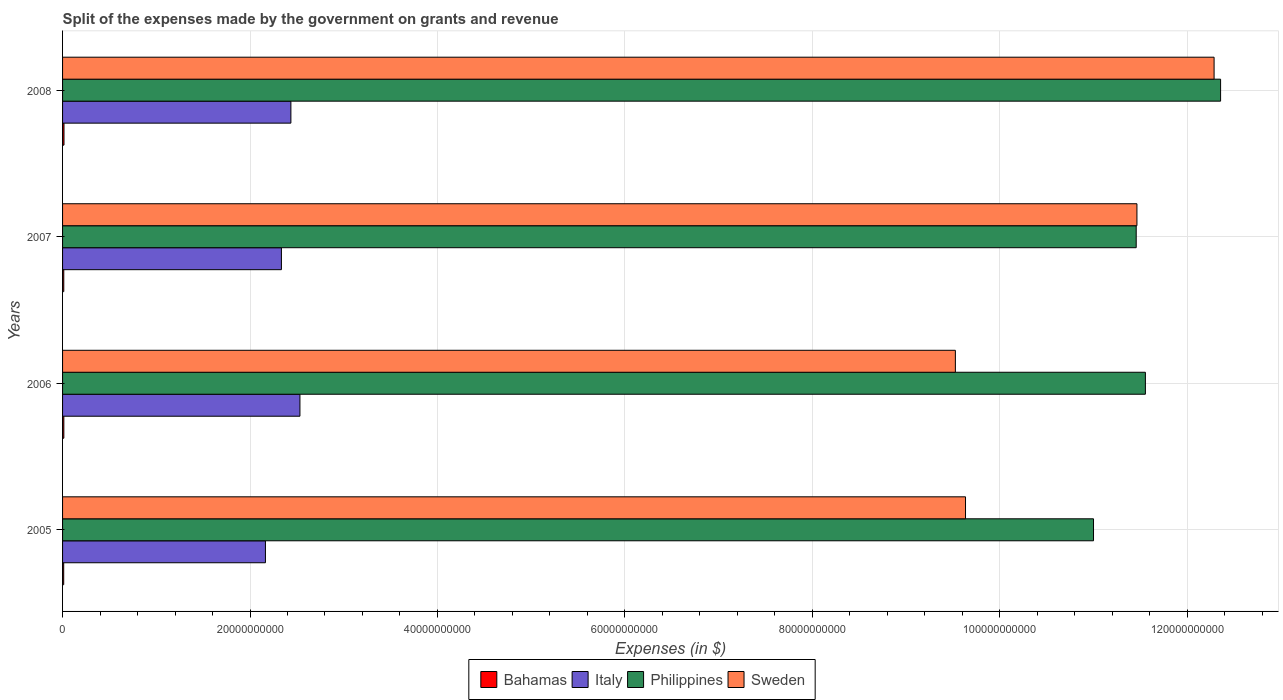How many different coloured bars are there?
Your answer should be compact. 4. Are the number of bars per tick equal to the number of legend labels?
Make the answer very short. Yes. How many bars are there on the 3rd tick from the top?
Provide a succinct answer. 4. How many bars are there on the 1st tick from the bottom?
Keep it short and to the point. 4. What is the label of the 4th group of bars from the top?
Keep it short and to the point. 2005. In how many cases, is the number of bars for a given year not equal to the number of legend labels?
Offer a very short reply. 0. What is the expenses made by the government on grants and revenue in Sweden in 2008?
Provide a short and direct response. 1.23e+11. Across all years, what is the maximum expenses made by the government on grants and revenue in Sweden?
Offer a terse response. 1.23e+11. Across all years, what is the minimum expenses made by the government on grants and revenue in Bahamas?
Your answer should be compact. 1.21e+08. In which year was the expenses made by the government on grants and revenue in Philippines maximum?
Your answer should be compact. 2008. In which year was the expenses made by the government on grants and revenue in Sweden minimum?
Your response must be concise. 2006. What is the total expenses made by the government on grants and revenue in Italy in the graph?
Provide a short and direct response. 9.47e+1. What is the difference between the expenses made by the government on grants and revenue in Philippines in 2005 and that in 2006?
Offer a terse response. -5.54e+09. What is the difference between the expenses made by the government on grants and revenue in Sweden in 2006 and the expenses made by the government on grants and revenue in Italy in 2007?
Offer a very short reply. 7.19e+1. What is the average expenses made by the government on grants and revenue in Bahamas per year?
Ensure brevity in your answer.  1.35e+08. In the year 2005, what is the difference between the expenses made by the government on grants and revenue in Philippines and expenses made by the government on grants and revenue in Sweden?
Give a very brief answer. 1.37e+1. What is the ratio of the expenses made by the government on grants and revenue in Philippines in 2007 to that in 2008?
Your response must be concise. 0.93. What is the difference between the highest and the second highest expenses made by the government on grants and revenue in Bahamas?
Keep it short and to the point. 1.60e+07. What is the difference between the highest and the lowest expenses made by the government on grants and revenue in Italy?
Ensure brevity in your answer.  3.68e+09. In how many years, is the expenses made by the government on grants and revenue in Bahamas greater than the average expenses made by the government on grants and revenue in Bahamas taken over all years?
Provide a short and direct response. 2. Is the sum of the expenses made by the government on grants and revenue in Italy in 2007 and 2008 greater than the maximum expenses made by the government on grants and revenue in Bahamas across all years?
Your answer should be very brief. Yes. How many bars are there?
Your response must be concise. 16. Are the values on the major ticks of X-axis written in scientific E-notation?
Keep it short and to the point. No. Where does the legend appear in the graph?
Your answer should be compact. Bottom center. How many legend labels are there?
Offer a terse response. 4. What is the title of the graph?
Provide a short and direct response. Split of the expenses made by the government on grants and revenue. What is the label or title of the X-axis?
Your answer should be very brief. Expenses (in $). What is the label or title of the Y-axis?
Your answer should be compact. Years. What is the Expenses (in $) of Bahamas in 2005?
Give a very brief answer. 1.21e+08. What is the Expenses (in $) of Italy in 2005?
Ensure brevity in your answer.  2.16e+1. What is the Expenses (in $) in Philippines in 2005?
Provide a short and direct response. 1.10e+11. What is the Expenses (in $) of Sweden in 2005?
Offer a terse response. 9.64e+1. What is the Expenses (in $) of Bahamas in 2006?
Your answer should be compact. 1.37e+08. What is the Expenses (in $) of Italy in 2006?
Offer a very short reply. 2.53e+1. What is the Expenses (in $) of Philippines in 2006?
Make the answer very short. 1.16e+11. What is the Expenses (in $) of Sweden in 2006?
Offer a very short reply. 9.53e+1. What is the Expenses (in $) in Bahamas in 2007?
Ensure brevity in your answer.  1.30e+08. What is the Expenses (in $) in Italy in 2007?
Provide a succinct answer. 2.34e+1. What is the Expenses (in $) in Philippines in 2007?
Provide a short and direct response. 1.15e+11. What is the Expenses (in $) of Sweden in 2007?
Keep it short and to the point. 1.15e+11. What is the Expenses (in $) of Bahamas in 2008?
Ensure brevity in your answer.  1.53e+08. What is the Expenses (in $) in Italy in 2008?
Offer a very short reply. 2.44e+1. What is the Expenses (in $) in Philippines in 2008?
Offer a terse response. 1.24e+11. What is the Expenses (in $) of Sweden in 2008?
Provide a succinct answer. 1.23e+11. Across all years, what is the maximum Expenses (in $) in Bahamas?
Keep it short and to the point. 1.53e+08. Across all years, what is the maximum Expenses (in $) in Italy?
Your answer should be compact. 2.53e+1. Across all years, what is the maximum Expenses (in $) in Philippines?
Your response must be concise. 1.24e+11. Across all years, what is the maximum Expenses (in $) of Sweden?
Offer a terse response. 1.23e+11. Across all years, what is the minimum Expenses (in $) of Bahamas?
Offer a very short reply. 1.21e+08. Across all years, what is the minimum Expenses (in $) of Italy?
Your answer should be very brief. 2.16e+1. Across all years, what is the minimum Expenses (in $) in Philippines?
Your answer should be compact. 1.10e+11. Across all years, what is the minimum Expenses (in $) in Sweden?
Provide a succinct answer. 9.53e+1. What is the total Expenses (in $) of Bahamas in the graph?
Provide a short and direct response. 5.41e+08. What is the total Expenses (in $) of Italy in the graph?
Keep it short and to the point. 9.47e+1. What is the total Expenses (in $) of Philippines in the graph?
Your answer should be very brief. 4.64e+11. What is the total Expenses (in $) of Sweden in the graph?
Give a very brief answer. 4.29e+11. What is the difference between the Expenses (in $) of Bahamas in 2005 and that in 2006?
Offer a terse response. -1.59e+07. What is the difference between the Expenses (in $) in Italy in 2005 and that in 2006?
Provide a succinct answer. -3.68e+09. What is the difference between the Expenses (in $) in Philippines in 2005 and that in 2006?
Your answer should be very brief. -5.54e+09. What is the difference between the Expenses (in $) in Sweden in 2005 and that in 2006?
Offer a terse response. 1.08e+09. What is the difference between the Expenses (in $) of Bahamas in 2005 and that in 2007?
Give a very brief answer. -9.02e+06. What is the difference between the Expenses (in $) in Italy in 2005 and that in 2007?
Offer a very short reply. -1.71e+09. What is the difference between the Expenses (in $) in Philippines in 2005 and that in 2007?
Provide a succinct answer. -4.56e+09. What is the difference between the Expenses (in $) in Sweden in 2005 and that in 2007?
Your answer should be compact. -1.83e+1. What is the difference between the Expenses (in $) in Bahamas in 2005 and that in 2008?
Offer a very short reply. -3.18e+07. What is the difference between the Expenses (in $) of Italy in 2005 and that in 2008?
Provide a succinct answer. -2.72e+09. What is the difference between the Expenses (in $) of Philippines in 2005 and that in 2008?
Your answer should be very brief. -1.36e+1. What is the difference between the Expenses (in $) in Sweden in 2005 and that in 2008?
Give a very brief answer. -2.65e+1. What is the difference between the Expenses (in $) in Bahamas in 2006 and that in 2007?
Your response must be concise. 6.84e+06. What is the difference between the Expenses (in $) of Italy in 2006 and that in 2007?
Ensure brevity in your answer.  1.98e+09. What is the difference between the Expenses (in $) of Philippines in 2006 and that in 2007?
Offer a terse response. 9.80e+08. What is the difference between the Expenses (in $) of Sweden in 2006 and that in 2007?
Your answer should be compact. -1.94e+1. What is the difference between the Expenses (in $) of Bahamas in 2006 and that in 2008?
Your answer should be very brief. -1.60e+07. What is the difference between the Expenses (in $) of Italy in 2006 and that in 2008?
Offer a terse response. 9.65e+08. What is the difference between the Expenses (in $) of Philippines in 2006 and that in 2008?
Give a very brief answer. -8.02e+09. What is the difference between the Expenses (in $) of Sweden in 2006 and that in 2008?
Your answer should be very brief. -2.76e+1. What is the difference between the Expenses (in $) in Bahamas in 2007 and that in 2008?
Offer a terse response. -2.28e+07. What is the difference between the Expenses (in $) in Italy in 2007 and that in 2008?
Give a very brief answer. -1.01e+09. What is the difference between the Expenses (in $) of Philippines in 2007 and that in 2008?
Provide a short and direct response. -9.00e+09. What is the difference between the Expenses (in $) in Sweden in 2007 and that in 2008?
Ensure brevity in your answer.  -8.23e+09. What is the difference between the Expenses (in $) in Bahamas in 2005 and the Expenses (in $) in Italy in 2006?
Provide a succinct answer. -2.52e+1. What is the difference between the Expenses (in $) of Bahamas in 2005 and the Expenses (in $) of Philippines in 2006?
Offer a very short reply. -1.15e+11. What is the difference between the Expenses (in $) in Bahamas in 2005 and the Expenses (in $) in Sweden in 2006?
Provide a succinct answer. -9.51e+1. What is the difference between the Expenses (in $) of Italy in 2005 and the Expenses (in $) of Philippines in 2006?
Your response must be concise. -9.39e+1. What is the difference between the Expenses (in $) in Italy in 2005 and the Expenses (in $) in Sweden in 2006?
Your answer should be very brief. -7.36e+1. What is the difference between the Expenses (in $) of Philippines in 2005 and the Expenses (in $) of Sweden in 2006?
Offer a terse response. 1.47e+1. What is the difference between the Expenses (in $) in Bahamas in 2005 and the Expenses (in $) in Italy in 2007?
Make the answer very short. -2.32e+1. What is the difference between the Expenses (in $) in Bahamas in 2005 and the Expenses (in $) in Philippines in 2007?
Provide a short and direct response. -1.14e+11. What is the difference between the Expenses (in $) of Bahamas in 2005 and the Expenses (in $) of Sweden in 2007?
Offer a terse response. -1.15e+11. What is the difference between the Expenses (in $) of Italy in 2005 and the Expenses (in $) of Philippines in 2007?
Make the answer very short. -9.29e+1. What is the difference between the Expenses (in $) in Italy in 2005 and the Expenses (in $) in Sweden in 2007?
Keep it short and to the point. -9.30e+1. What is the difference between the Expenses (in $) in Philippines in 2005 and the Expenses (in $) in Sweden in 2007?
Give a very brief answer. -4.63e+09. What is the difference between the Expenses (in $) in Bahamas in 2005 and the Expenses (in $) in Italy in 2008?
Provide a short and direct response. -2.42e+1. What is the difference between the Expenses (in $) of Bahamas in 2005 and the Expenses (in $) of Philippines in 2008?
Your response must be concise. -1.23e+11. What is the difference between the Expenses (in $) in Bahamas in 2005 and the Expenses (in $) in Sweden in 2008?
Your response must be concise. -1.23e+11. What is the difference between the Expenses (in $) in Italy in 2005 and the Expenses (in $) in Philippines in 2008?
Make the answer very short. -1.02e+11. What is the difference between the Expenses (in $) in Italy in 2005 and the Expenses (in $) in Sweden in 2008?
Offer a very short reply. -1.01e+11. What is the difference between the Expenses (in $) in Philippines in 2005 and the Expenses (in $) in Sweden in 2008?
Ensure brevity in your answer.  -1.29e+1. What is the difference between the Expenses (in $) in Bahamas in 2006 and the Expenses (in $) in Italy in 2007?
Your response must be concise. -2.32e+1. What is the difference between the Expenses (in $) of Bahamas in 2006 and the Expenses (in $) of Philippines in 2007?
Your answer should be compact. -1.14e+11. What is the difference between the Expenses (in $) of Bahamas in 2006 and the Expenses (in $) of Sweden in 2007?
Give a very brief answer. -1.15e+11. What is the difference between the Expenses (in $) in Italy in 2006 and the Expenses (in $) in Philippines in 2007?
Offer a very short reply. -8.92e+1. What is the difference between the Expenses (in $) of Italy in 2006 and the Expenses (in $) of Sweden in 2007?
Your answer should be compact. -8.93e+1. What is the difference between the Expenses (in $) of Philippines in 2006 and the Expenses (in $) of Sweden in 2007?
Provide a short and direct response. 9.02e+08. What is the difference between the Expenses (in $) in Bahamas in 2006 and the Expenses (in $) in Italy in 2008?
Your answer should be compact. -2.42e+1. What is the difference between the Expenses (in $) of Bahamas in 2006 and the Expenses (in $) of Philippines in 2008?
Offer a very short reply. -1.23e+11. What is the difference between the Expenses (in $) in Bahamas in 2006 and the Expenses (in $) in Sweden in 2008?
Give a very brief answer. -1.23e+11. What is the difference between the Expenses (in $) of Italy in 2006 and the Expenses (in $) of Philippines in 2008?
Ensure brevity in your answer.  -9.82e+1. What is the difference between the Expenses (in $) of Italy in 2006 and the Expenses (in $) of Sweden in 2008?
Provide a succinct answer. -9.75e+1. What is the difference between the Expenses (in $) of Philippines in 2006 and the Expenses (in $) of Sweden in 2008?
Your response must be concise. -7.33e+09. What is the difference between the Expenses (in $) in Bahamas in 2007 and the Expenses (in $) in Italy in 2008?
Provide a short and direct response. -2.42e+1. What is the difference between the Expenses (in $) in Bahamas in 2007 and the Expenses (in $) in Philippines in 2008?
Your answer should be very brief. -1.23e+11. What is the difference between the Expenses (in $) of Bahamas in 2007 and the Expenses (in $) of Sweden in 2008?
Offer a terse response. -1.23e+11. What is the difference between the Expenses (in $) of Italy in 2007 and the Expenses (in $) of Philippines in 2008?
Ensure brevity in your answer.  -1.00e+11. What is the difference between the Expenses (in $) in Italy in 2007 and the Expenses (in $) in Sweden in 2008?
Provide a succinct answer. -9.95e+1. What is the difference between the Expenses (in $) of Philippines in 2007 and the Expenses (in $) of Sweden in 2008?
Ensure brevity in your answer.  -8.31e+09. What is the average Expenses (in $) in Bahamas per year?
Your answer should be very brief. 1.35e+08. What is the average Expenses (in $) of Italy per year?
Give a very brief answer. 2.37e+1. What is the average Expenses (in $) in Philippines per year?
Your answer should be compact. 1.16e+11. What is the average Expenses (in $) of Sweden per year?
Provide a succinct answer. 1.07e+11. In the year 2005, what is the difference between the Expenses (in $) of Bahamas and Expenses (in $) of Italy?
Ensure brevity in your answer.  -2.15e+1. In the year 2005, what is the difference between the Expenses (in $) in Bahamas and Expenses (in $) in Philippines?
Offer a terse response. -1.10e+11. In the year 2005, what is the difference between the Expenses (in $) in Bahamas and Expenses (in $) in Sweden?
Provide a short and direct response. -9.62e+1. In the year 2005, what is the difference between the Expenses (in $) in Italy and Expenses (in $) in Philippines?
Your answer should be very brief. -8.84e+1. In the year 2005, what is the difference between the Expenses (in $) of Italy and Expenses (in $) of Sweden?
Ensure brevity in your answer.  -7.47e+1. In the year 2005, what is the difference between the Expenses (in $) of Philippines and Expenses (in $) of Sweden?
Give a very brief answer. 1.37e+1. In the year 2006, what is the difference between the Expenses (in $) in Bahamas and Expenses (in $) in Italy?
Your answer should be very brief. -2.52e+1. In the year 2006, what is the difference between the Expenses (in $) in Bahamas and Expenses (in $) in Philippines?
Provide a succinct answer. -1.15e+11. In the year 2006, what is the difference between the Expenses (in $) of Bahamas and Expenses (in $) of Sweden?
Your answer should be compact. -9.51e+1. In the year 2006, what is the difference between the Expenses (in $) of Italy and Expenses (in $) of Philippines?
Ensure brevity in your answer.  -9.02e+1. In the year 2006, what is the difference between the Expenses (in $) of Italy and Expenses (in $) of Sweden?
Your answer should be very brief. -6.99e+1. In the year 2006, what is the difference between the Expenses (in $) in Philippines and Expenses (in $) in Sweden?
Keep it short and to the point. 2.03e+1. In the year 2007, what is the difference between the Expenses (in $) of Bahamas and Expenses (in $) of Italy?
Ensure brevity in your answer.  -2.32e+1. In the year 2007, what is the difference between the Expenses (in $) of Bahamas and Expenses (in $) of Philippines?
Ensure brevity in your answer.  -1.14e+11. In the year 2007, what is the difference between the Expenses (in $) in Bahamas and Expenses (in $) in Sweden?
Give a very brief answer. -1.15e+11. In the year 2007, what is the difference between the Expenses (in $) of Italy and Expenses (in $) of Philippines?
Keep it short and to the point. -9.12e+1. In the year 2007, what is the difference between the Expenses (in $) of Italy and Expenses (in $) of Sweden?
Your answer should be very brief. -9.13e+1. In the year 2007, what is the difference between the Expenses (in $) in Philippines and Expenses (in $) in Sweden?
Your response must be concise. -7.80e+07. In the year 2008, what is the difference between the Expenses (in $) in Bahamas and Expenses (in $) in Italy?
Provide a short and direct response. -2.42e+1. In the year 2008, what is the difference between the Expenses (in $) of Bahamas and Expenses (in $) of Philippines?
Provide a short and direct response. -1.23e+11. In the year 2008, what is the difference between the Expenses (in $) in Bahamas and Expenses (in $) in Sweden?
Provide a succinct answer. -1.23e+11. In the year 2008, what is the difference between the Expenses (in $) of Italy and Expenses (in $) of Philippines?
Offer a very short reply. -9.92e+1. In the year 2008, what is the difference between the Expenses (in $) of Italy and Expenses (in $) of Sweden?
Your answer should be compact. -9.85e+1. In the year 2008, what is the difference between the Expenses (in $) of Philippines and Expenses (in $) of Sweden?
Offer a very short reply. 6.94e+08. What is the ratio of the Expenses (in $) in Bahamas in 2005 to that in 2006?
Your answer should be very brief. 0.88. What is the ratio of the Expenses (in $) of Italy in 2005 to that in 2006?
Provide a succinct answer. 0.85. What is the ratio of the Expenses (in $) of Philippines in 2005 to that in 2006?
Your answer should be very brief. 0.95. What is the ratio of the Expenses (in $) of Sweden in 2005 to that in 2006?
Your answer should be compact. 1.01. What is the ratio of the Expenses (in $) of Bahamas in 2005 to that in 2007?
Your answer should be compact. 0.93. What is the ratio of the Expenses (in $) of Italy in 2005 to that in 2007?
Make the answer very short. 0.93. What is the ratio of the Expenses (in $) of Philippines in 2005 to that in 2007?
Give a very brief answer. 0.96. What is the ratio of the Expenses (in $) of Sweden in 2005 to that in 2007?
Ensure brevity in your answer.  0.84. What is the ratio of the Expenses (in $) in Bahamas in 2005 to that in 2008?
Provide a short and direct response. 0.79. What is the ratio of the Expenses (in $) in Italy in 2005 to that in 2008?
Provide a succinct answer. 0.89. What is the ratio of the Expenses (in $) in Philippines in 2005 to that in 2008?
Provide a succinct answer. 0.89. What is the ratio of the Expenses (in $) in Sweden in 2005 to that in 2008?
Offer a very short reply. 0.78. What is the ratio of the Expenses (in $) in Bahamas in 2006 to that in 2007?
Provide a short and direct response. 1.05. What is the ratio of the Expenses (in $) in Italy in 2006 to that in 2007?
Your answer should be very brief. 1.08. What is the ratio of the Expenses (in $) in Philippines in 2006 to that in 2007?
Your response must be concise. 1.01. What is the ratio of the Expenses (in $) of Sweden in 2006 to that in 2007?
Ensure brevity in your answer.  0.83. What is the ratio of the Expenses (in $) in Bahamas in 2006 to that in 2008?
Ensure brevity in your answer.  0.9. What is the ratio of the Expenses (in $) of Italy in 2006 to that in 2008?
Your response must be concise. 1.04. What is the ratio of the Expenses (in $) of Philippines in 2006 to that in 2008?
Give a very brief answer. 0.94. What is the ratio of the Expenses (in $) of Sweden in 2006 to that in 2008?
Your answer should be very brief. 0.78. What is the ratio of the Expenses (in $) of Bahamas in 2007 to that in 2008?
Offer a very short reply. 0.85. What is the ratio of the Expenses (in $) of Italy in 2007 to that in 2008?
Provide a succinct answer. 0.96. What is the ratio of the Expenses (in $) of Philippines in 2007 to that in 2008?
Offer a terse response. 0.93. What is the ratio of the Expenses (in $) in Sweden in 2007 to that in 2008?
Your answer should be very brief. 0.93. What is the difference between the highest and the second highest Expenses (in $) in Bahamas?
Offer a very short reply. 1.60e+07. What is the difference between the highest and the second highest Expenses (in $) in Italy?
Give a very brief answer. 9.65e+08. What is the difference between the highest and the second highest Expenses (in $) of Philippines?
Provide a short and direct response. 8.02e+09. What is the difference between the highest and the second highest Expenses (in $) of Sweden?
Provide a short and direct response. 8.23e+09. What is the difference between the highest and the lowest Expenses (in $) in Bahamas?
Your answer should be very brief. 3.18e+07. What is the difference between the highest and the lowest Expenses (in $) of Italy?
Offer a very short reply. 3.68e+09. What is the difference between the highest and the lowest Expenses (in $) in Philippines?
Provide a succinct answer. 1.36e+1. What is the difference between the highest and the lowest Expenses (in $) of Sweden?
Your answer should be very brief. 2.76e+1. 